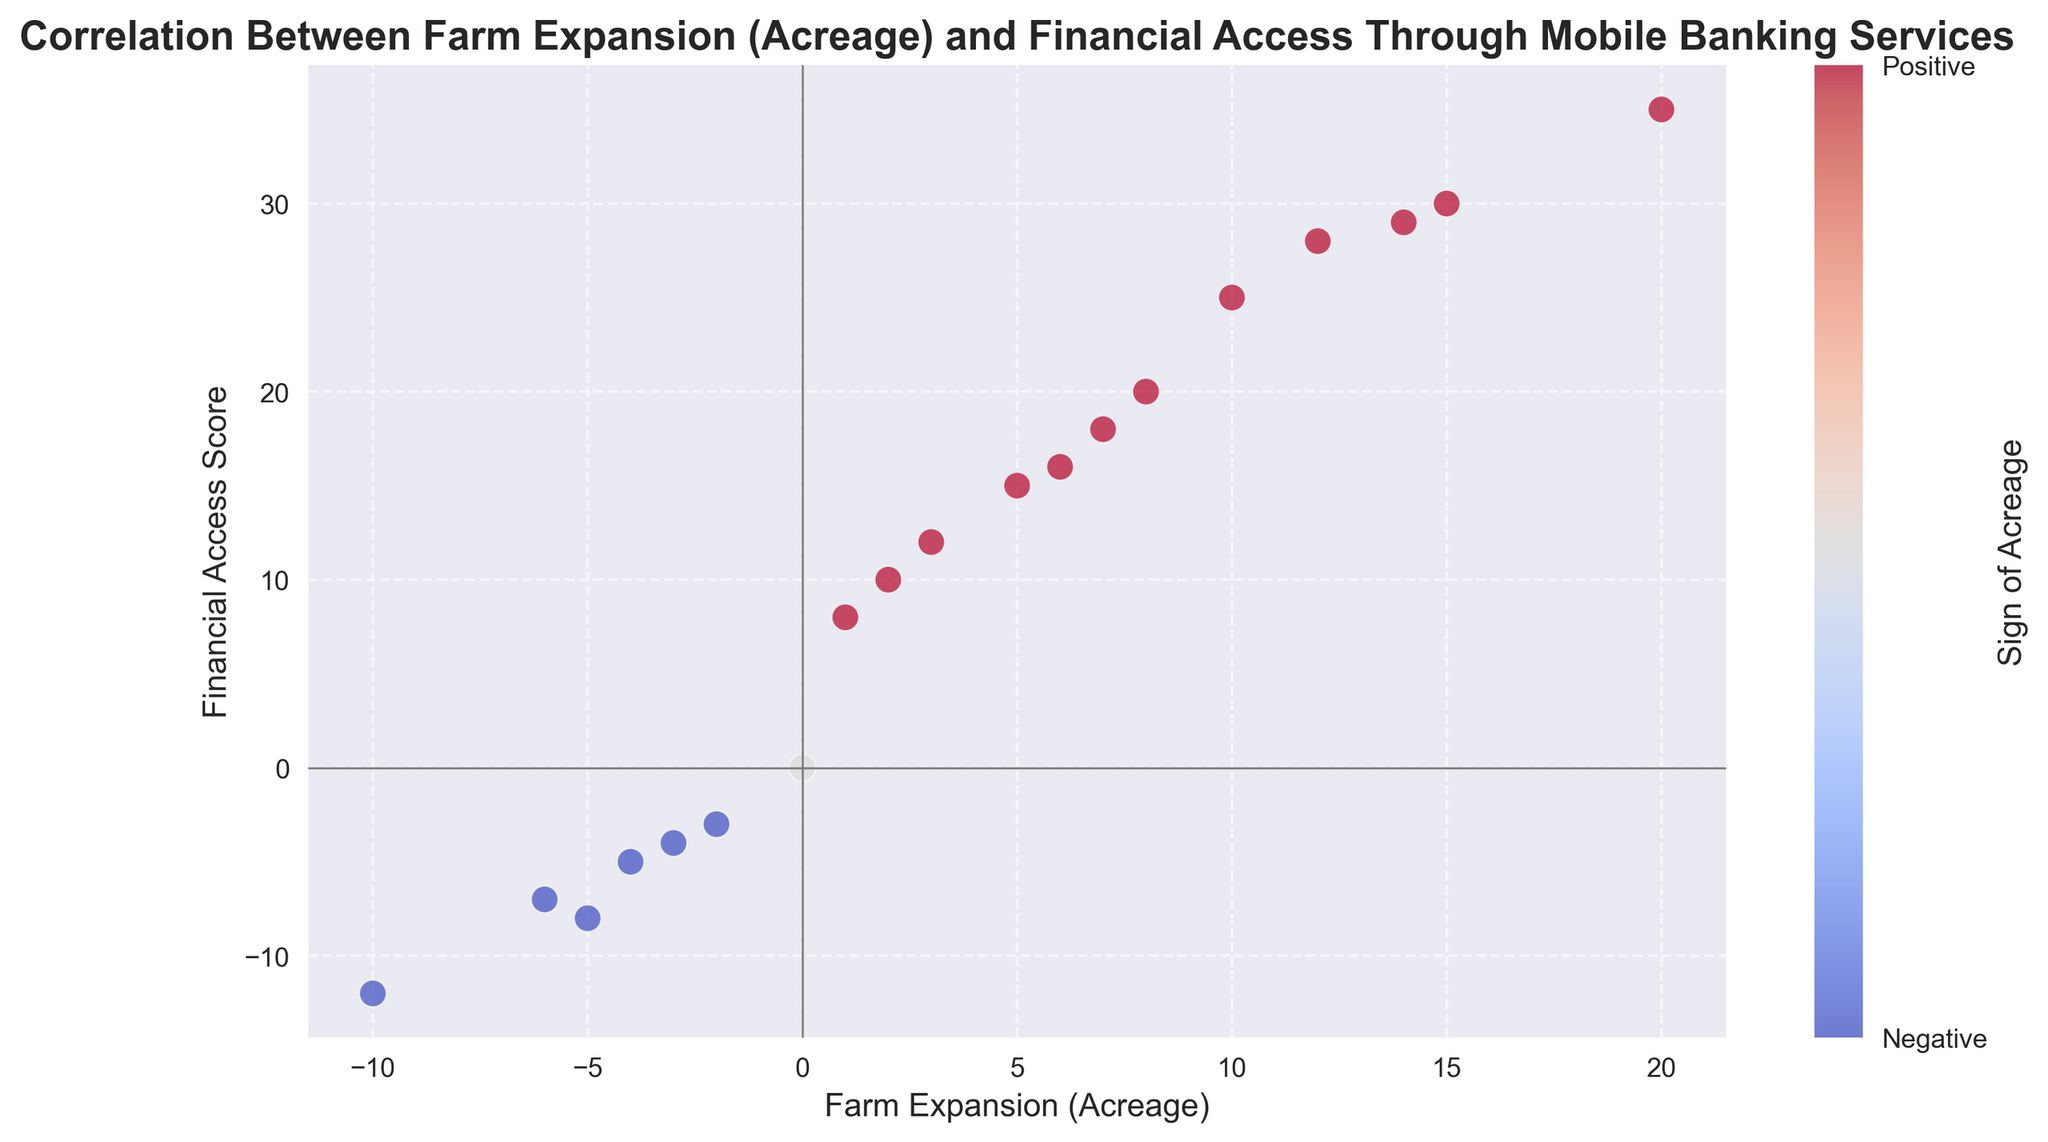What is the highest Financial Access Score for a positive acreage value? The highest Financial Access Score for positive acreage can be found by identifying the largest y-value among the points with positive x-values. Here, the highest Financial Access Score is 35.
Answer: 35 What is the relationship between acreage and Financial Access Score? To determine the relationship, observe the trend in the scatter plot. Positive acreage values are generally associated with higher Financial Access Scores, indicating a positive correlation, while negative values are associated with lower scores, showing a negative correlation.
Answer: Positive correlation How many data points lie in the negative acreage value region? To find the number of data points in the negative acreage region, count the points with negative x-values. There are six such points: (-4,-5), (-2,-3), (-5,-8), (-3,-4), (-10,-12), and (-6,-7).
Answer: 6 Which has the greater increase per unit increase in acreage - positive or negative values? To find this, look at the slopes of the points in each region. Positive acreages show a steep increase in Financial Access Score per unit increase, whereas negative acreages show a less steep decline. Hence, positive values have a greater increase per unit increase in acreage.
Answer: Positive values What trend can be observed in the visual attributes of the scatter plot with respect to color and values of acreage? The scatter plot uses a color gradient to indicate the sign of acreage; positive values are in a warm color (e.g., red) and negative values are in a cool color (e.g., blue). This helps to visually distinguish the positive and negative acreage regions.
Answer: Red for positive, blue for negative What is the average Financial Access Score for acreages of 5 and above? Calculate the average Financial Access Score for acreages ≥ 5: (15 + 20 + 18 + 25 + 30 + 35 + 28 + 16 + 29) / 9 = 23. In this case, sum the scores 15 + 20 + 18 + 25 + 30 + 35 + 28 + 16 + 29 = 216, then divide by the number of points (9).
Answer: 24 What can you say about points that lie on the y-axis or x-axis? Points on the y-axis (where Acreage is 0) show Financial Access Scores around 0, indicating no significant correlation with financial access. Points on the x-axis (where Financial Access Score is 0) show an acreage of 0, signifying no farm expansion.
Answer: Scores around 0 & no farm expansion Is there any point with a Financial Access Score of 0? Inspect the scatter plot; there is a data point located at the origin (0,0), which has a Financial Access Score of 0.
Answer: Yes How do the Financial Access Scores differ for the highest and lowest acreage values? The highest acreage is 20, with a Financial Access Score of 35. The lowest acreage is -10, with a Financial Access Score of -12. There is a stark difference, with the highest values showing much higher Financial Access Scores.
Answer: 47 units difference Among the given data points, what is the median Financial Access Score for positive acreages? First, list the Financial Access Scores for positive acreages: [10, 8, 15, 12, 20, 18, 25, 30, 35, 28, 16, 29]. The median is the middle value of this sorted list. (20 + 18)/2 = 19.5.
Answer: 19.5 